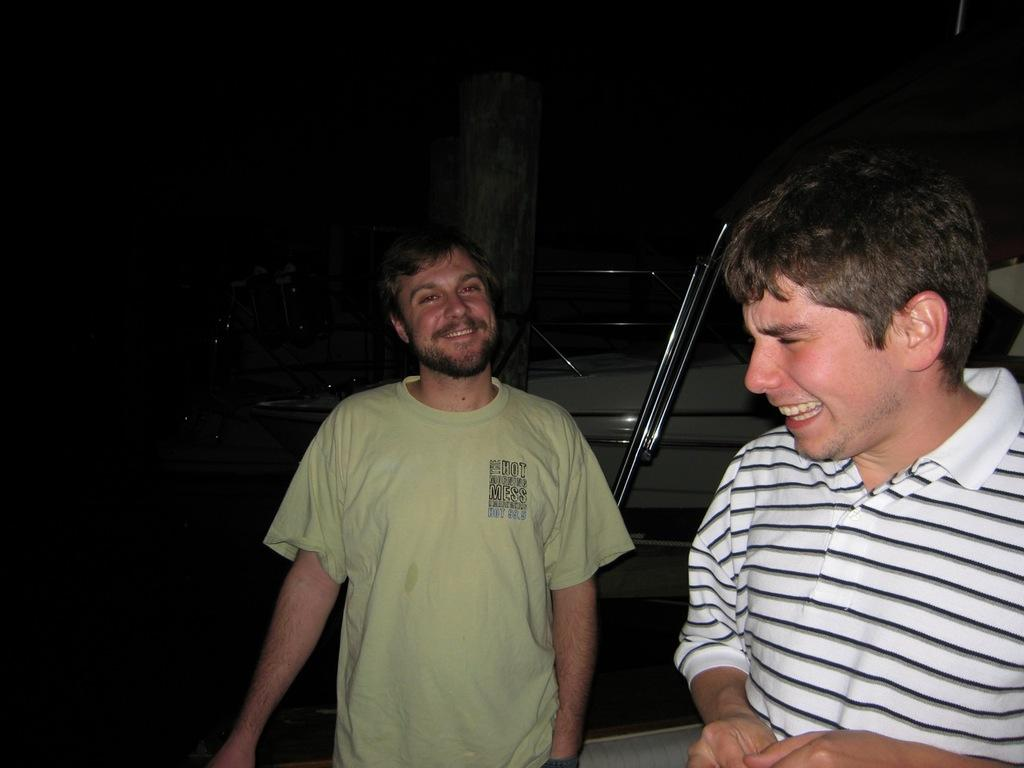What time of day was the image taken? The image was taken at night. How many people are in the foreground of the image? There are two persons in the foreground. What is the facial expression of the people in the image? Both persons are smiling. What can be seen in the middle of the image? There is a vehicle and a pole in the middle of the image. What type of account is being discussed by the persons in the image? There is no indication in the image that the persons are discussing any type of account. Is there any rice visible in the image? No, there is no rice present in the image. 